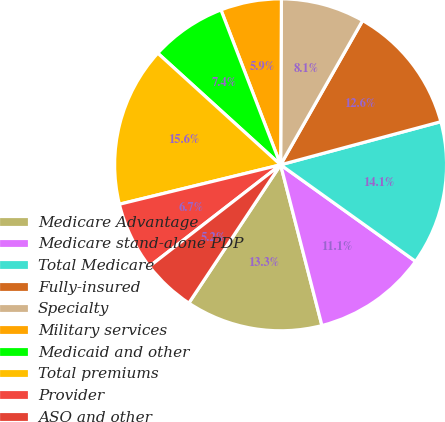<chart> <loc_0><loc_0><loc_500><loc_500><pie_chart><fcel>Medicare Advantage<fcel>Medicare stand-alone PDP<fcel>Total Medicare<fcel>Fully-insured<fcel>Specialty<fcel>Military services<fcel>Medicaid and other<fcel>Total premiums<fcel>Provider<fcel>ASO and other<nl><fcel>13.33%<fcel>11.11%<fcel>14.07%<fcel>12.59%<fcel>8.15%<fcel>5.93%<fcel>7.41%<fcel>15.56%<fcel>6.67%<fcel>5.19%<nl></chart> 